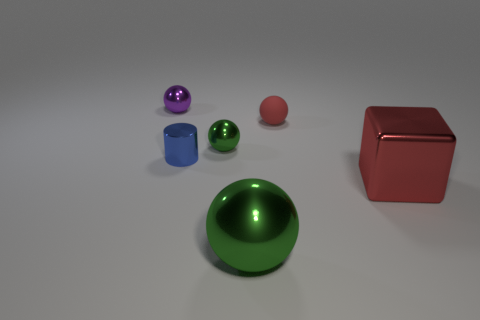What size is the metallic cube that is the same color as the small rubber ball?
Offer a very short reply. Large. What is the material of the other object that is the same color as the small rubber object?
Ensure brevity in your answer.  Metal. How big is the green ball that is on the left side of the big green metal thing?
Provide a succinct answer. Small. Is there another tiny shiny cube of the same color as the shiny block?
Your response must be concise. No. Is the size of the green shiny sphere that is in front of the red metal cube the same as the metal block?
Your answer should be very brief. Yes. The small cylinder is what color?
Offer a terse response. Blue. The small metallic ball in front of the thing on the left side of the metal cylinder is what color?
Give a very brief answer. Green. Is there a tiny purple object that has the same material as the tiny blue object?
Your answer should be very brief. Yes. There is a small sphere on the left side of the green sphere behind the big red block; what is its material?
Ensure brevity in your answer.  Metal. How many small purple objects are the same shape as the big red shiny thing?
Keep it short and to the point. 0. 